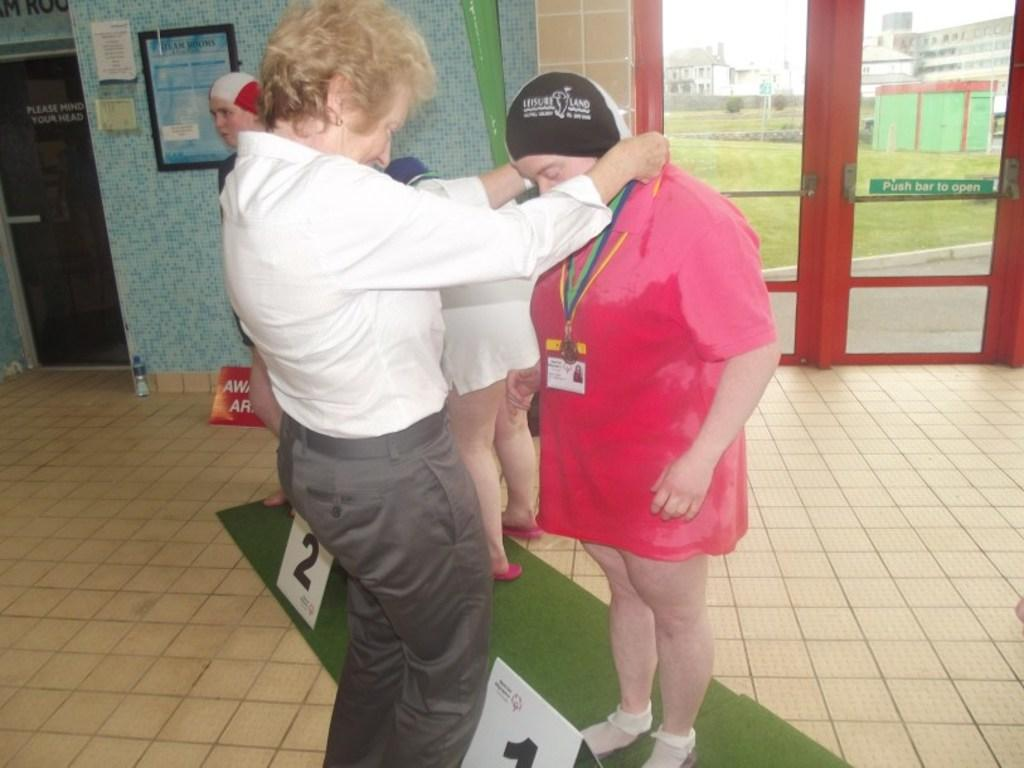What can be seen in the image? There are people standing in the image. What type of architectural feature is present in the image? There is a glass door in the image. What is the background of the image? There is a wall in the image, and green grass on the ground in the background. What type of plant is growing on the stem in the image? There is no plant or stem present in the image. What unit of measurement is used to determine the height of the people in the image? The facts provided do not mention any unit of measurement, so it cannot be determined from the image. 